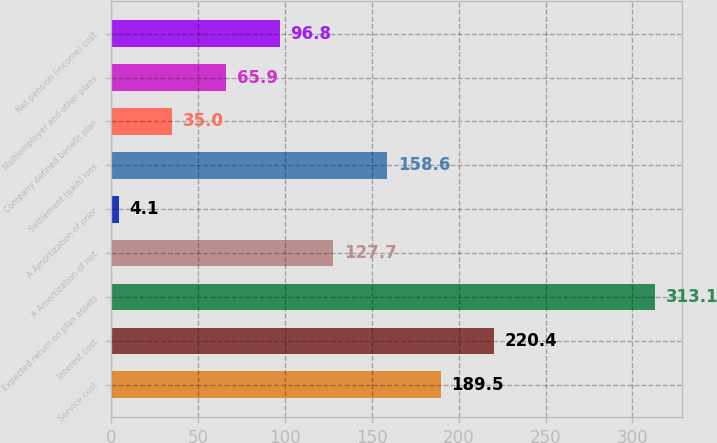Convert chart to OTSL. <chart><loc_0><loc_0><loc_500><loc_500><bar_chart><fcel>Service cost<fcel>Interest cost<fcel>Expected return on plan assets<fcel>A Amortization of net<fcel>A Amortization of prior<fcel>Settlement (gain) loss<fcel>Company defined benefit plan<fcel>Multiemployer and other plans<fcel>Net pension (income) cost<nl><fcel>189.5<fcel>220.4<fcel>313.1<fcel>127.7<fcel>4.1<fcel>158.6<fcel>35<fcel>65.9<fcel>96.8<nl></chart> 